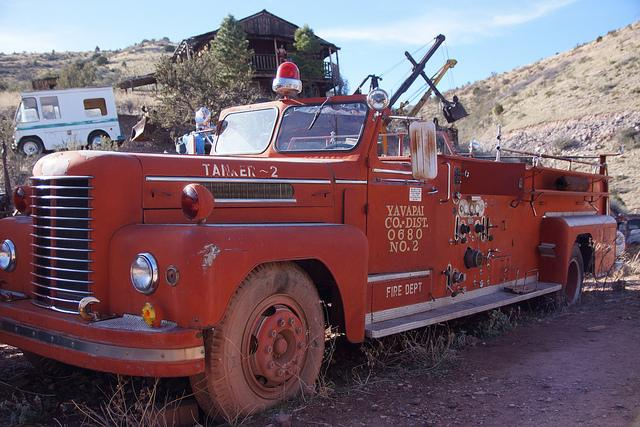What sort of emergency is the truck seen here prepared to immediately handle?

Choices:
A) break ins
B) none
C) heart attack
D) towing none 